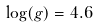Convert formula to latex. <formula><loc_0><loc_0><loc_500><loc_500>\log ( g ) = 4 . 6</formula> 